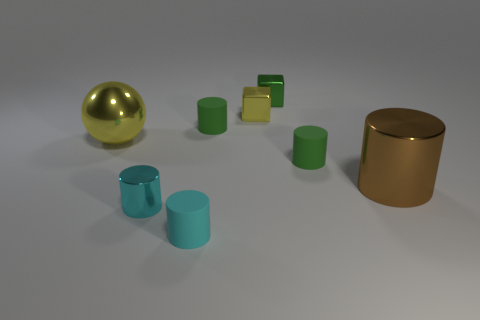Subtract all brown cylinders. How many cylinders are left? 4 Subtract all brown cylinders. How many cylinders are left? 4 Subtract all brown cylinders. Subtract all gray balls. How many cylinders are left? 4 Add 2 brown cylinders. How many objects exist? 10 Subtract all blocks. How many objects are left? 6 Add 6 tiny brown spheres. How many tiny brown spheres exist? 6 Subtract 0 purple cylinders. How many objects are left? 8 Subtract all metal things. Subtract all blocks. How many objects are left? 1 Add 7 yellow balls. How many yellow balls are left? 8 